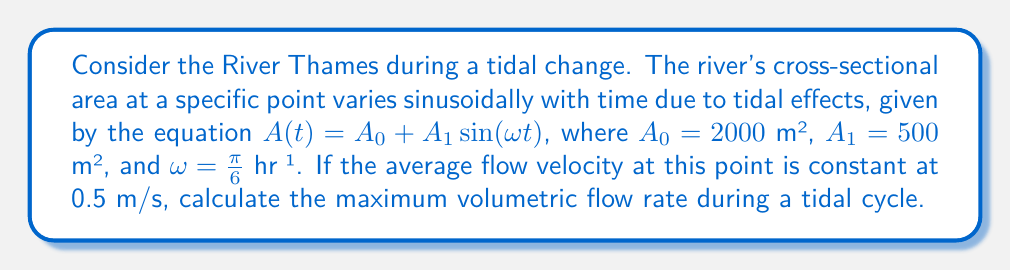Provide a solution to this math problem. To solve this problem, we'll follow these steps:

1) The volumetric flow rate $Q$ is given by the product of cross-sectional area $A$ and flow velocity $v$:

   $$Q = A \cdot v$$

2) We're given that the velocity is constant at 0.5 m/s, so we can focus on finding the maximum cross-sectional area.

3) The cross-sectional area varies according to:

   $$A(t) = A_0 + A_1 \sin(\omega t)$$

   Where $A_0 = 2000$ m², $A_1 = 500$ m², and $\omega = \frac{\pi}{6}$ hr⁻¹

4) The maximum area will occur when $\sin(\omega t) = 1$, which gives:

   $$A_{max} = A_0 + A_1 = 2000 + 500 = 2500 \text{ m²}$$

5) Now we can calculate the maximum flow rate:

   $$Q_{max} = A_{max} \cdot v = 2500 \text{ m²} \cdot 0.5 \text{ m/s} = 1250 \text{ m³/s}$$

Therefore, the maximum volumetric flow rate during a tidal cycle is 1250 m³/s.
Answer: 1250 m³/s 